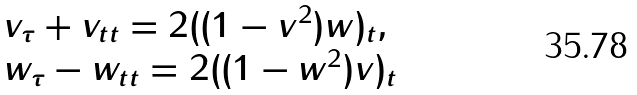<formula> <loc_0><loc_0><loc_500><loc_500>\begin{array} { l l } v _ { \tau } + v _ { t t } = 2 ( ( 1 - v ^ { 2 } ) w ) _ { t } , \\ w _ { \tau } - w _ { t t } = 2 ( ( 1 - w ^ { 2 } ) v ) _ { t } \end{array}</formula> 